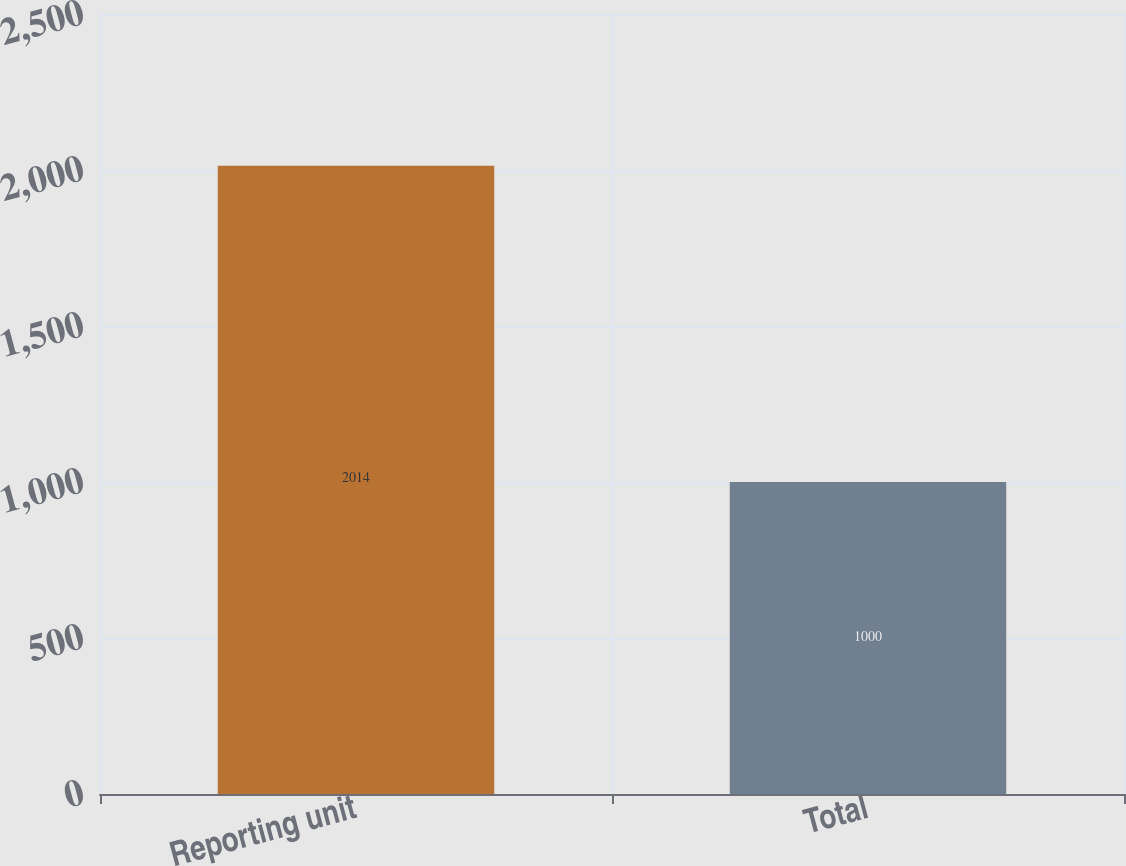<chart> <loc_0><loc_0><loc_500><loc_500><bar_chart><fcel>Reporting unit<fcel>Total<nl><fcel>2014<fcel>1000<nl></chart> 